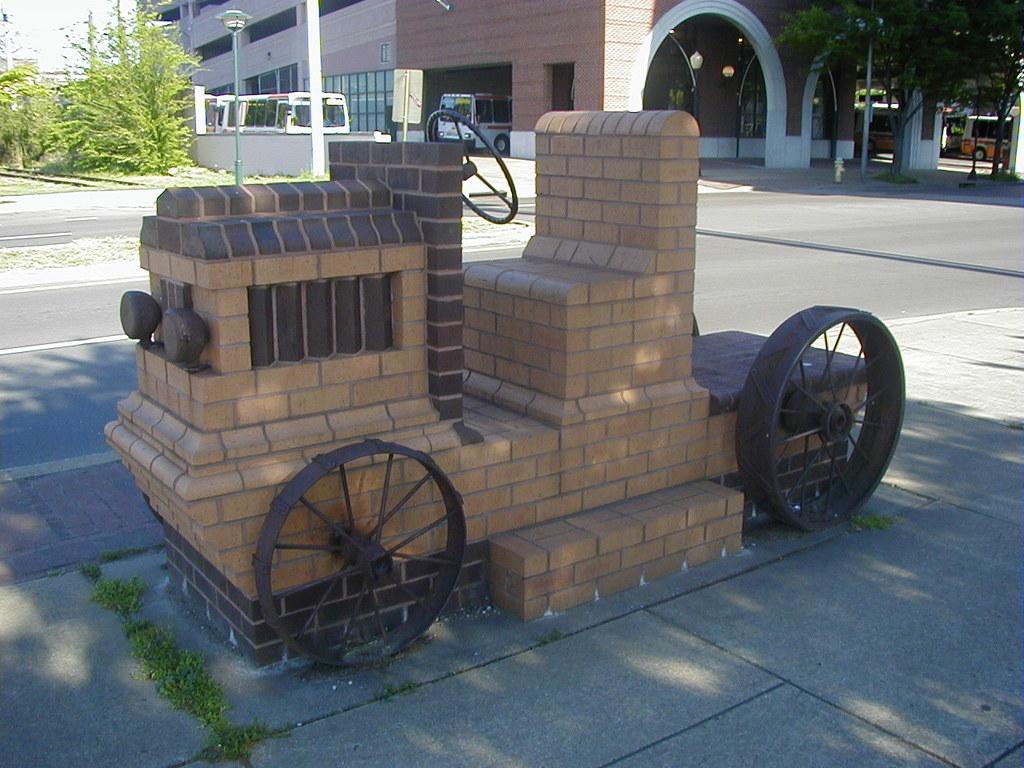How would you summarize this image in a sentence or two? In this image I can see the structure of the vehicle which is made up of brick. To the side I can see the road. In the background I can see the poles, many trees, few vehicles and the building. I can also see the sky 